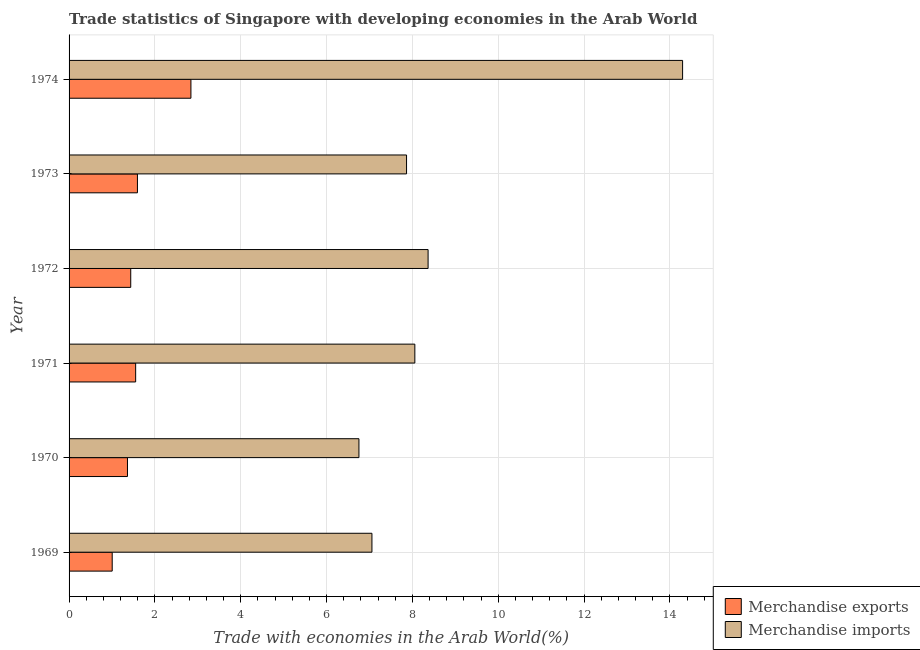How many different coloured bars are there?
Offer a very short reply. 2. How many bars are there on the 6th tick from the bottom?
Make the answer very short. 2. What is the merchandise imports in 1974?
Your response must be concise. 14.29. Across all years, what is the maximum merchandise imports?
Keep it short and to the point. 14.29. Across all years, what is the minimum merchandise exports?
Make the answer very short. 1. In which year was the merchandise imports maximum?
Ensure brevity in your answer.  1974. In which year was the merchandise imports minimum?
Provide a succinct answer. 1970. What is the total merchandise imports in the graph?
Keep it short and to the point. 52.39. What is the difference between the merchandise imports in 1972 and that in 1974?
Keep it short and to the point. -5.93. What is the difference between the merchandise exports in 1974 and the merchandise imports in 1973?
Provide a succinct answer. -5.02. What is the average merchandise imports per year?
Ensure brevity in your answer.  8.73. In the year 1970, what is the difference between the merchandise imports and merchandise exports?
Keep it short and to the point. 5.39. What is the ratio of the merchandise exports in 1969 to that in 1973?
Your answer should be compact. 0.63. Is the merchandise imports in 1970 less than that in 1972?
Your response must be concise. Yes. Is the difference between the merchandise exports in 1970 and 1973 greater than the difference between the merchandise imports in 1970 and 1973?
Provide a succinct answer. Yes. What is the difference between the highest and the second highest merchandise imports?
Give a very brief answer. 5.93. What is the difference between the highest and the lowest merchandise exports?
Your answer should be very brief. 1.83. What does the 2nd bar from the top in 1972 represents?
Your answer should be very brief. Merchandise exports. Are all the bars in the graph horizontal?
Make the answer very short. Yes. How many years are there in the graph?
Your response must be concise. 6. What is the difference between two consecutive major ticks on the X-axis?
Give a very brief answer. 2. Where does the legend appear in the graph?
Ensure brevity in your answer.  Bottom right. What is the title of the graph?
Provide a short and direct response. Trade statistics of Singapore with developing economies in the Arab World. What is the label or title of the X-axis?
Provide a short and direct response. Trade with economies in the Arab World(%). What is the label or title of the Y-axis?
Your response must be concise. Year. What is the Trade with economies in the Arab World(%) in Merchandise exports in 1969?
Offer a very short reply. 1. What is the Trade with economies in the Arab World(%) in Merchandise imports in 1969?
Offer a very short reply. 7.06. What is the Trade with economies in the Arab World(%) in Merchandise exports in 1970?
Offer a terse response. 1.36. What is the Trade with economies in the Arab World(%) of Merchandise imports in 1970?
Provide a succinct answer. 6.75. What is the Trade with economies in the Arab World(%) in Merchandise exports in 1971?
Make the answer very short. 1.55. What is the Trade with economies in the Arab World(%) of Merchandise imports in 1971?
Offer a terse response. 8.06. What is the Trade with economies in the Arab World(%) of Merchandise exports in 1972?
Your response must be concise. 1.44. What is the Trade with economies in the Arab World(%) of Merchandise imports in 1972?
Give a very brief answer. 8.36. What is the Trade with economies in the Arab World(%) of Merchandise exports in 1973?
Make the answer very short. 1.59. What is the Trade with economies in the Arab World(%) of Merchandise imports in 1973?
Offer a very short reply. 7.86. What is the Trade with economies in the Arab World(%) in Merchandise exports in 1974?
Provide a succinct answer. 2.84. What is the Trade with economies in the Arab World(%) of Merchandise imports in 1974?
Provide a succinct answer. 14.29. Across all years, what is the maximum Trade with economies in the Arab World(%) of Merchandise exports?
Your answer should be very brief. 2.84. Across all years, what is the maximum Trade with economies in the Arab World(%) in Merchandise imports?
Offer a very short reply. 14.29. Across all years, what is the minimum Trade with economies in the Arab World(%) in Merchandise exports?
Provide a short and direct response. 1. Across all years, what is the minimum Trade with economies in the Arab World(%) in Merchandise imports?
Ensure brevity in your answer.  6.75. What is the total Trade with economies in the Arab World(%) in Merchandise exports in the graph?
Make the answer very short. 9.79. What is the total Trade with economies in the Arab World(%) in Merchandise imports in the graph?
Keep it short and to the point. 52.39. What is the difference between the Trade with economies in the Arab World(%) of Merchandise exports in 1969 and that in 1970?
Keep it short and to the point. -0.36. What is the difference between the Trade with economies in the Arab World(%) of Merchandise imports in 1969 and that in 1970?
Give a very brief answer. 0.3. What is the difference between the Trade with economies in the Arab World(%) in Merchandise exports in 1969 and that in 1971?
Offer a terse response. -0.55. What is the difference between the Trade with economies in the Arab World(%) in Merchandise imports in 1969 and that in 1971?
Offer a very short reply. -1. What is the difference between the Trade with economies in the Arab World(%) in Merchandise exports in 1969 and that in 1972?
Ensure brevity in your answer.  -0.43. What is the difference between the Trade with economies in the Arab World(%) of Merchandise imports in 1969 and that in 1972?
Your response must be concise. -1.31. What is the difference between the Trade with economies in the Arab World(%) of Merchandise exports in 1969 and that in 1973?
Offer a terse response. -0.59. What is the difference between the Trade with economies in the Arab World(%) in Merchandise imports in 1969 and that in 1973?
Make the answer very short. -0.81. What is the difference between the Trade with economies in the Arab World(%) of Merchandise exports in 1969 and that in 1974?
Provide a succinct answer. -1.83. What is the difference between the Trade with economies in the Arab World(%) in Merchandise imports in 1969 and that in 1974?
Your response must be concise. -7.24. What is the difference between the Trade with economies in the Arab World(%) of Merchandise exports in 1970 and that in 1971?
Offer a very short reply. -0.19. What is the difference between the Trade with economies in the Arab World(%) of Merchandise imports in 1970 and that in 1971?
Provide a succinct answer. -1.3. What is the difference between the Trade with economies in the Arab World(%) of Merchandise exports in 1970 and that in 1972?
Make the answer very short. -0.08. What is the difference between the Trade with economies in the Arab World(%) in Merchandise imports in 1970 and that in 1972?
Provide a short and direct response. -1.61. What is the difference between the Trade with economies in the Arab World(%) of Merchandise exports in 1970 and that in 1973?
Offer a terse response. -0.23. What is the difference between the Trade with economies in the Arab World(%) of Merchandise imports in 1970 and that in 1973?
Offer a very short reply. -1.11. What is the difference between the Trade with economies in the Arab World(%) of Merchandise exports in 1970 and that in 1974?
Provide a short and direct response. -1.48. What is the difference between the Trade with economies in the Arab World(%) of Merchandise imports in 1970 and that in 1974?
Provide a succinct answer. -7.54. What is the difference between the Trade with economies in the Arab World(%) of Merchandise exports in 1971 and that in 1972?
Keep it short and to the point. 0.11. What is the difference between the Trade with economies in the Arab World(%) of Merchandise imports in 1971 and that in 1972?
Provide a succinct answer. -0.31. What is the difference between the Trade with economies in the Arab World(%) of Merchandise exports in 1971 and that in 1973?
Your response must be concise. -0.04. What is the difference between the Trade with economies in the Arab World(%) of Merchandise imports in 1971 and that in 1973?
Provide a short and direct response. 0.19. What is the difference between the Trade with economies in the Arab World(%) of Merchandise exports in 1971 and that in 1974?
Your response must be concise. -1.29. What is the difference between the Trade with economies in the Arab World(%) of Merchandise imports in 1971 and that in 1974?
Your response must be concise. -6.24. What is the difference between the Trade with economies in the Arab World(%) in Merchandise exports in 1972 and that in 1973?
Keep it short and to the point. -0.16. What is the difference between the Trade with economies in the Arab World(%) of Merchandise imports in 1972 and that in 1973?
Offer a very short reply. 0.5. What is the difference between the Trade with economies in the Arab World(%) of Merchandise exports in 1972 and that in 1974?
Provide a succinct answer. -1.4. What is the difference between the Trade with economies in the Arab World(%) in Merchandise imports in 1972 and that in 1974?
Offer a very short reply. -5.93. What is the difference between the Trade with economies in the Arab World(%) of Merchandise exports in 1973 and that in 1974?
Keep it short and to the point. -1.25. What is the difference between the Trade with economies in the Arab World(%) of Merchandise imports in 1973 and that in 1974?
Keep it short and to the point. -6.43. What is the difference between the Trade with economies in the Arab World(%) in Merchandise exports in 1969 and the Trade with economies in the Arab World(%) in Merchandise imports in 1970?
Provide a short and direct response. -5.75. What is the difference between the Trade with economies in the Arab World(%) of Merchandise exports in 1969 and the Trade with economies in the Arab World(%) of Merchandise imports in 1971?
Your answer should be compact. -7.05. What is the difference between the Trade with economies in the Arab World(%) in Merchandise exports in 1969 and the Trade with economies in the Arab World(%) in Merchandise imports in 1972?
Your answer should be very brief. -7.36. What is the difference between the Trade with economies in the Arab World(%) in Merchandise exports in 1969 and the Trade with economies in the Arab World(%) in Merchandise imports in 1973?
Keep it short and to the point. -6.86. What is the difference between the Trade with economies in the Arab World(%) in Merchandise exports in 1969 and the Trade with economies in the Arab World(%) in Merchandise imports in 1974?
Offer a very short reply. -13.29. What is the difference between the Trade with economies in the Arab World(%) in Merchandise exports in 1970 and the Trade with economies in the Arab World(%) in Merchandise imports in 1971?
Provide a short and direct response. -6.7. What is the difference between the Trade with economies in the Arab World(%) in Merchandise exports in 1970 and the Trade with economies in the Arab World(%) in Merchandise imports in 1972?
Make the answer very short. -7. What is the difference between the Trade with economies in the Arab World(%) of Merchandise exports in 1970 and the Trade with economies in the Arab World(%) of Merchandise imports in 1973?
Offer a terse response. -6.5. What is the difference between the Trade with economies in the Arab World(%) of Merchandise exports in 1970 and the Trade with economies in the Arab World(%) of Merchandise imports in 1974?
Your answer should be compact. -12.93. What is the difference between the Trade with economies in the Arab World(%) of Merchandise exports in 1971 and the Trade with economies in the Arab World(%) of Merchandise imports in 1972?
Provide a succinct answer. -6.81. What is the difference between the Trade with economies in the Arab World(%) in Merchandise exports in 1971 and the Trade with economies in the Arab World(%) in Merchandise imports in 1973?
Your answer should be very brief. -6.31. What is the difference between the Trade with economies in the Arab World(%) in Merchandise exports in 1971 and the Trade with economies in the Arab World(%) in Merchandise imports in 1974?
Keep it short and to the point. -12.74. What is the difference between the Trade with economies in the Arab World(%) in Merchandise exports in 1972 and the Trade with economies in the Arab World(%) in Merchandise imports in 1973?
Give a very brief answer. -6.43. What is the difference between the Trade with economies in the Arab World(%) in Merchandise exports in 1972 and the Trade with economies in the Arab World(%) in Merchandise imports in 1974?
Provide a succinct answer. -12.86. What is the difference between the Trade with economies in the Arab World(%) in Merchandise exports in 1973 and the Trade with economies in the Arab World(%) in Merchandise imports in 1974?
Provide a short and direct response. -12.7. What is the average Trade with economies in the Arab World(%) in Merchandise exports per year?
Your response must be concise. 1.63. What is the average Trade with economies in the Arab World(%) of Merchandise imports per year?
Your response must be concise. 8.73. In the year 1969, what is the difference between the Trade with economies in the Arab World(%) of Merchandise exports and Trade with economies in the Arab World(%) of Merchandise imports?
Offer a terse response. -6.05. In the year 1970, what is the difference between the Trade with economies in the Arab World(%) in Merchandise exports and Trade with economies in the Arab World(%) in Merchandise imports?
Provide a succinct answer. -5.39. In the year 1971, what is the difference between the Trade with economies in the Arab World(%) in Merchandise exports and Trade with economies in the Arab World(%) in Merchandise imports?
Your response must be concise. -6.5. In the year 1972, what is the difference between the Trade with economies in the Arab World(%) in Merchandise exports and Trade with economies in the Arab World(%) in Merchandise imports?
Your response must be concise. -6.93. In the year 1973, what is the difference between the Trade with economies in the Arab World(%) in Merchandise exports and Trade with economies in the Arab World(%) in Merchandise imports?
Give a very brief answer. -6.27. In the year 1974, what is the difference between the Trade with economies in the Arab World(%) of Merchandise exports and Trade with economies in the Arab World(%) of Merchandise imports?
Ensure brevity in your answer.  -11.45. What is the ratio of the Trade with economies in the Arab World(%) of Merchandise exports in 1969 to that in 1970?
Offer a very short reply. 0.74. What is the ratio of the Trade with economies in the Arab World(%) in Merchandise imports in 1969 to that in 1970?
Your answer should be very brief. 1.04. What is the ratio of the Trade with economies in the Arab World(%) in Merchandise exports in 1969 to that in 1971?
Your answer should be very brief. 0.65. What is the ratio of the Trade with economies in the Arab World(%) of Merchandise imports in 1969 to that in 1971?
Give a very brief answer. 0.88. What is the ratio of the Trade with economies in the Arab World(%) in Merchandise exports in 1969 to that in 1972?
Provide a succinct answer. 0.7. What is the ratio of the Trade with economies in the Arab World(%) of Merchandise imports in 1969 to that in 1972?
Keep it short and to the point. 0.84. What is the ratio of the Trade with economies in the Arab World(%) of Merchandise exports in 1969 to that in 1973?
Offer a terse response. 0.63. What is the ratio of the Trade with economies in the Arab World(%) in Merchandise imports in 1969 to that in 1973?
Your answer should be compact. 0.9. What is the ratio of the Trade with economies in the Arab World(%) of Merchandise exports in 1969 to that in 1974?
Your answer should be very brief. 0.35. What is the ratio of the Trade with economies in the Arab World(%) of Merchandise imports in 1969 to that in 1974?
Make the answer very short. 0.49. What is the ratio of the Trade with economies in the Arab World(%) of Merchandise exports in 1970 to that in 1971?
Ensure brevity in your answer.  0.88. What is the ratio of the Trade with economies in the Arab World(%) in Merchandise imports in 1970 to that in 1971?
Ensure brevity in your answer.  0.84. What is the ratio of the Trade with economies in the Arab World(%) of Merchandise exports in 1970 to that in 1972?
Provide a short and direct response. 0.95. What is the ratio of the Trade with economies in the Arab World(%) of Merchandise imports in 1970 to that in 1972?
Keep it short and to the point. 0.81. What is the ratio of the Trade with economies in the Arab World(%) in Merchandise exports in 1970 to that in 1973?
Keep it short and to the point. 0.85. What is the ratio of the Trade with economies in the Arab World(%) in Merchandise imports in 1970 to that in 1973?
Keep it short and to the point. 0.86. What is the ratio of the Trade with economies in the Arab World(%) of Merchandise exports in 1970 to that in 1974?
Offer a terse response. 0.48. What is the ratio of the Trade with economies in the Arab World(%) of Merchandise imports in 1970 to that in 1974?
Provide a succinct answer. 0.47. What is the ratio of the Trade with economies in the Arab World(%) of Merchandise imports in 1971 to that in 1972?
Give a very brief answer. 0.96. What is the ratio of the Trade with economies in the Arab World(%) of Merchandise exports in 1971 to that in 1973?
Provide a succinct answer. 0.97. What is the ratio of the Trade with economies in the Arab World(%) of Merchandise imports in 1971 to that in 1973?
Keep it short and to the point. 1.02. What is the ratio of the Trade with economies in the Arab World(%) in Merchandise exports in 1971 to that in 1974?
Your answer should be very brief. 0.55. What is the ratio of the Trade with economies in the Arab World(%) in Merchandise imports in 1971 to that in 1974?
Give a very brief answer. 0.56. What is the ratio of the Trade with economies in the Arab World(%) in Merchandise exports in 1972 to that in 1973?
Ensure brevity in your answer.  0.9. What is the ratio of the Trade with economies in the Arab World(%) of Merchandise imports in 1972 to that in 1973?
Ensure brevity in your answer.  1.06. What is the ratio of the Trade with economies in the Arab World(%) in Merchandise exports in 1972 to that in 1974?
Provide a short and direct response. 0.51. What is the ratio of the Trade with economies in the Arab World(%) in Merchandise imports in 1972 to that in 1974?
Your answer should be compact. 0.59. What is the ratio of the Trade with economies in the Arab World(%) in Merchandise exports in 1973 to that in 1974?
Make the answer very short. 0.56. What is the ratio of the Trade with economies in the Arab World(%) in Merchandise imports in 1973 to that in 1974?
Offer a very short reply. 0.55. What is the difference between the highest and the second highest Trade with economies in the Arab World(%) of Merchandise exports?
Make the answer very short. 1.25. What is the difference between the highest and the second highest Trade with economies in the Arab World(%) of Merchandise imports?
Provide a short and direct response. 5.93. What is the difference between the highest and the lowest Trade with economies in the Arab World(%) in Merchandise exports?
Your answer should be compact. 1.83. What is the difference between the highest and the lowest Trade with economies in the Arab World(%) of Merchandise imports?
Ensure brevity in your answer.  7.54. 